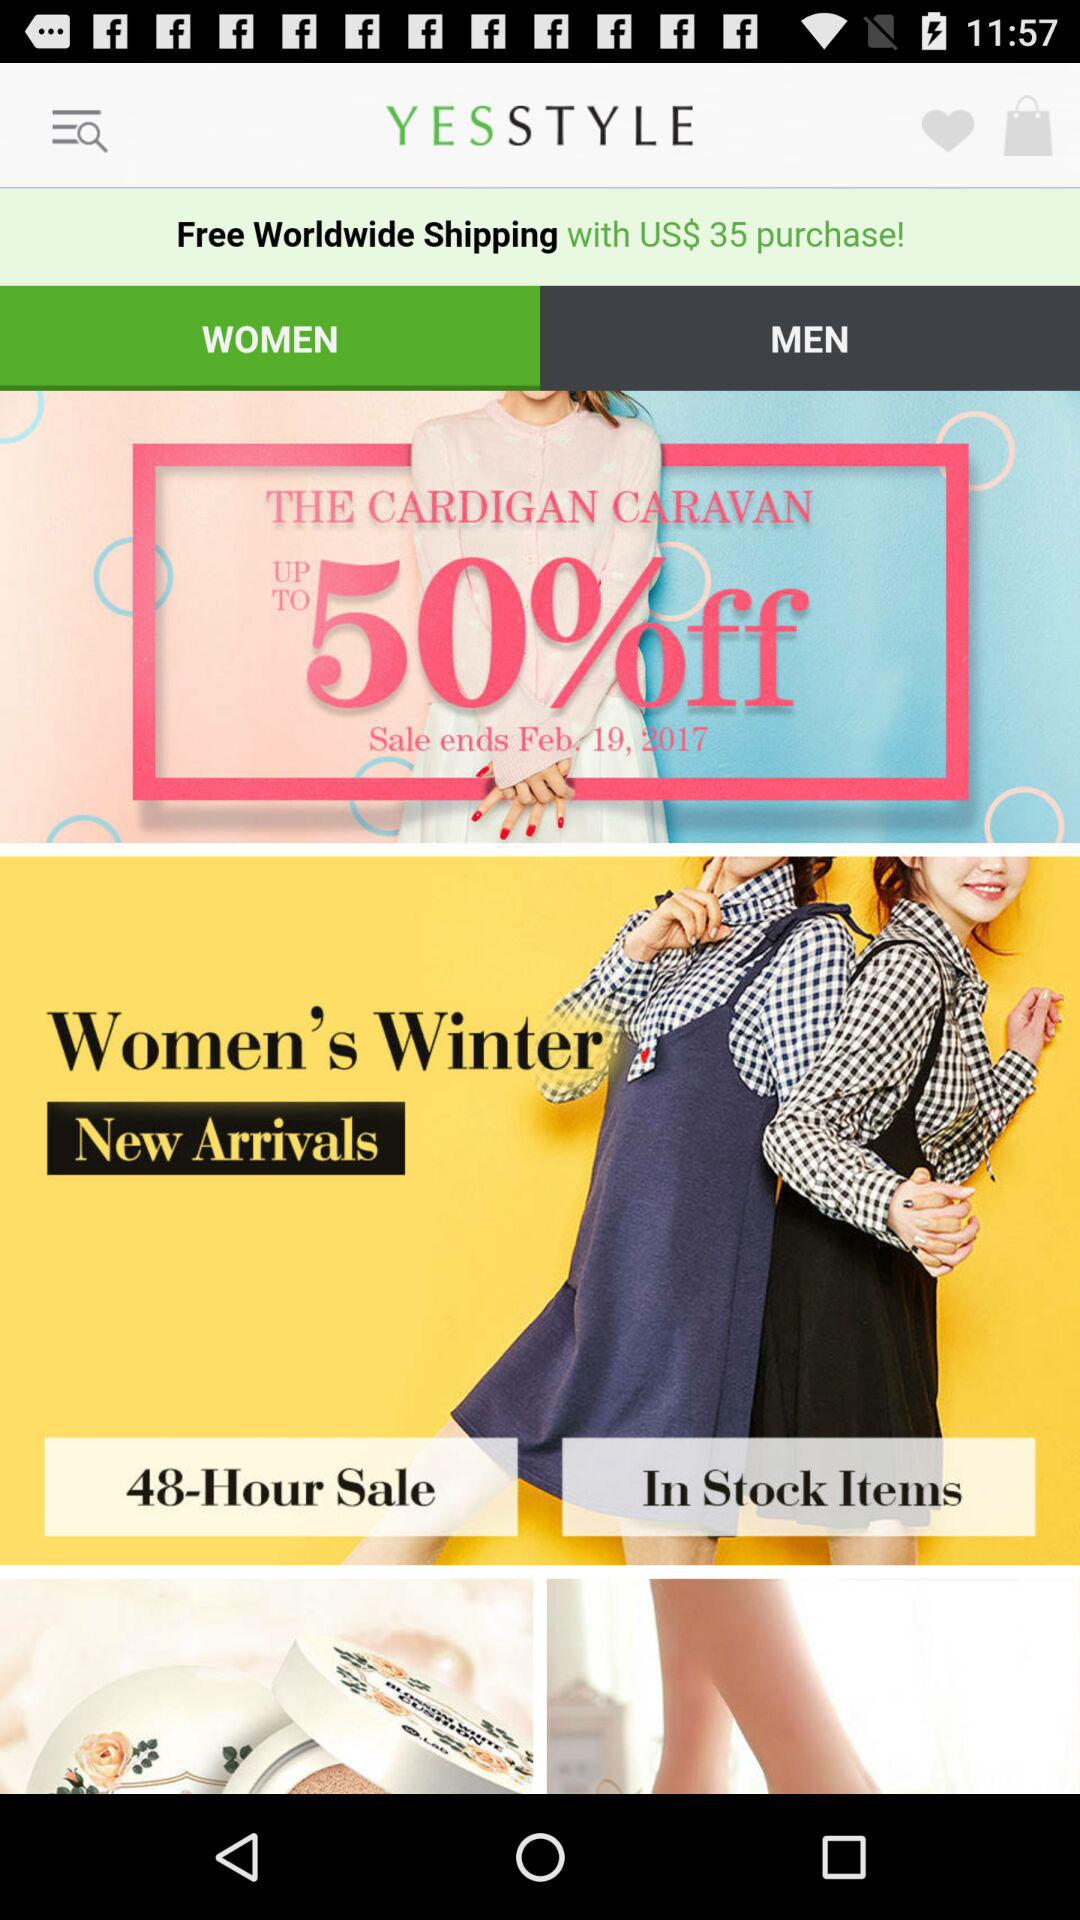What is the end date of the sale? The end date of the sale is February 19, 2017. 